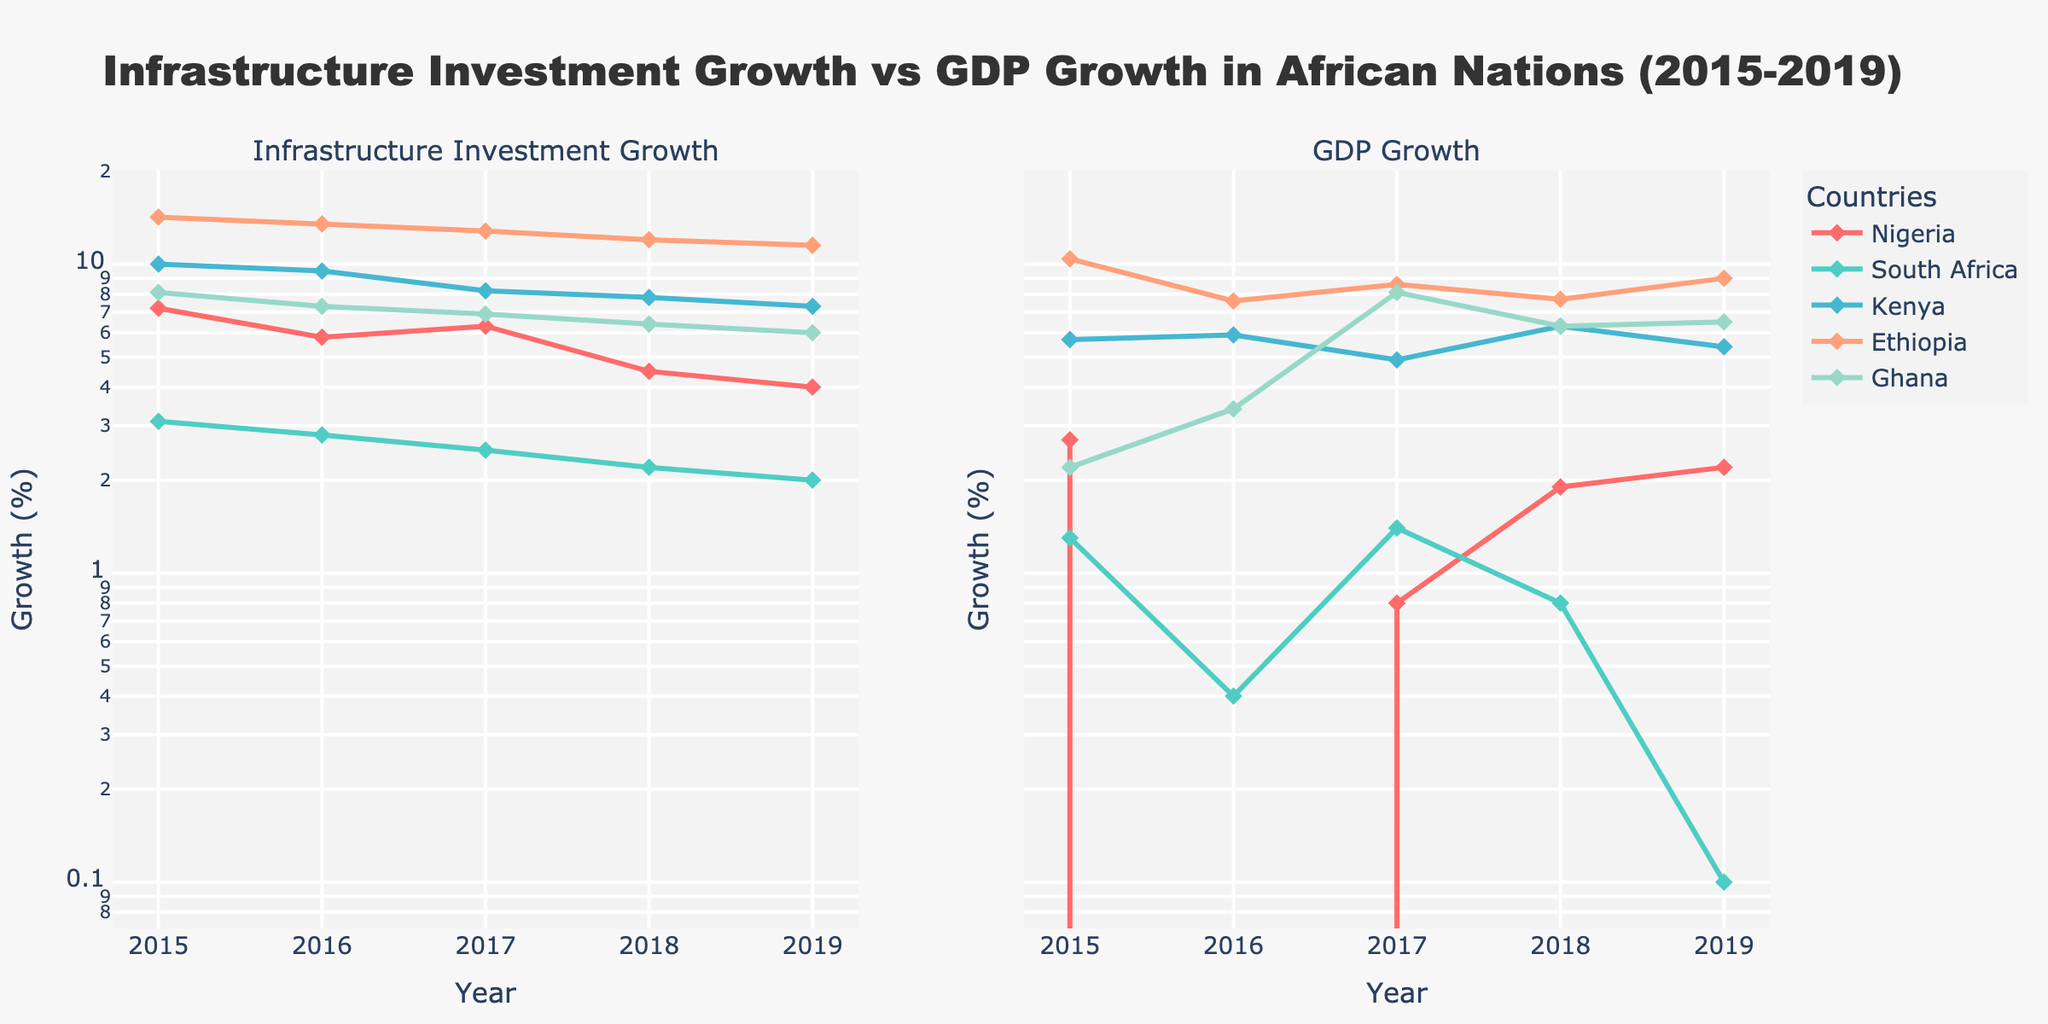What is the title of the plot? The title of the plot is displayed prominently at the top. It states: "Infrastructure Investment Growth vs GDP Growth in African Nations (2015-2019)".
Answer: Infrastructure Investment Growth vs GDP Growth in African Nations (2015-2019) Which country had the highest infrastructure investment growth in 2015? By looking at the left subplot for the year 2015, Ethiopia had the highest infrastructure investment growth rate which is above 14%.
Answer: Ethiopia How does Nigeria's infrastructure investment growth in 2019 compare to its GDP growth in the same year? In 2019, Nigeria's infrastructure investment growth was 4%, whereas the GDP growth was 2.2%. A comparison indicates that infrastructure investment growth was nearly double the GDP growth.
Answer: Infrastructure investment growth was higher Which country displayed consistent growth in both infrastructure investment and GDP from 2015 to 2019? Kenya displayed relatively consistent growth in both infrastructure investment and GDP from 2015 to 2019 in the right subplot. The lines show smaller fluctuations and maintain a positive trend.
Answer: Kenya By how much did Ethiopia's GDP growth reduce from 2018 to 2019? From the right subplot, Ethiopia's GDP growth in 2018 was around 7.7%, and in 2019 it was 9.0%. The value increased by approximately 1.3%.
Answer: Increased by 1.3% What general trend do you observe in South Africa's GDP growth between 2015 and 2019? In the right subplot, South Africa's GDP growth shows a general declining trend from 1.3% in 2015 to a lower value of 0.1% by 2019.
Answer: Declining trend Which country had the lowest infrastructure investment growth in 2019? By looking at the left subplot for the year 2019, South Africa had the lowest infrastructure investment growth rate which is around 2.0%.
Answer: South Africa Compare Kenya's infrastructure investment growth in 2016 and 2017. Looking at the left subplot, Kenya's infrastructure investment growth was 9.5% in 2016 and 8.2% in 2017. It decreased by 1.3% from 2016 to 2017.
Answer: Decreased by 1.3% Is there any country where GDP growth was negative at any point during 2015-2019? By observing the right subplot, Nigeria experienced a negative GDP growth in 2016 which was around -1.6%.
Answer: Nigeria in 2016 Do the log scales affect the visualization of any particular year's data point substantially? Log scales help visualize data in a way that patterns and differences are clearer, especially for smaller values. In this plot, it helps differentiate smaller growth percentages more clearly, especially for South Africa's lower GDP growth rates.
Answer: Clarifies smaller growth differences 